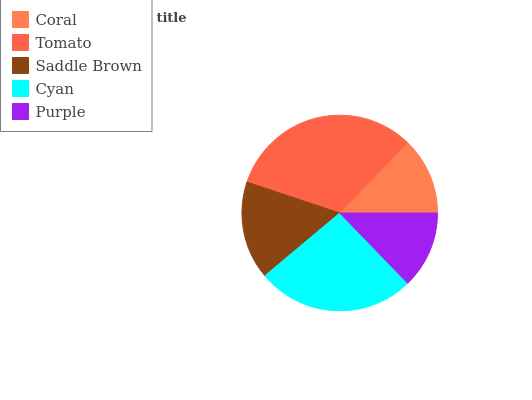Is Purple the minimum?
Answer yes or no. Yes. Is Tomato the maximum?
Answer yes or no. Yes. Is Saddle Brown the minimum?
Answer yes or no. No. Is Saddle Brown the maximum?
Answer yes or no. No. Is Tomato greater than Saddle Brown?
Answer yes or no. Yes. Is Saddle Brown less than Tomato?
Answer yes or no. Yes. Is Saddle Brown greater than Tomato?
Answer yes or no. No. Is Tomato less than Saddle Brown?
Answer yes or no. No. Is Saddle Brown the high median?
Answer yes or no. Yes. Is Saddle Brown the low median?
Answer yes or no. Yes. Is Coral the high median?
Answer yes or no. No. Is Purple the low median?
Answer yes or no. No. 